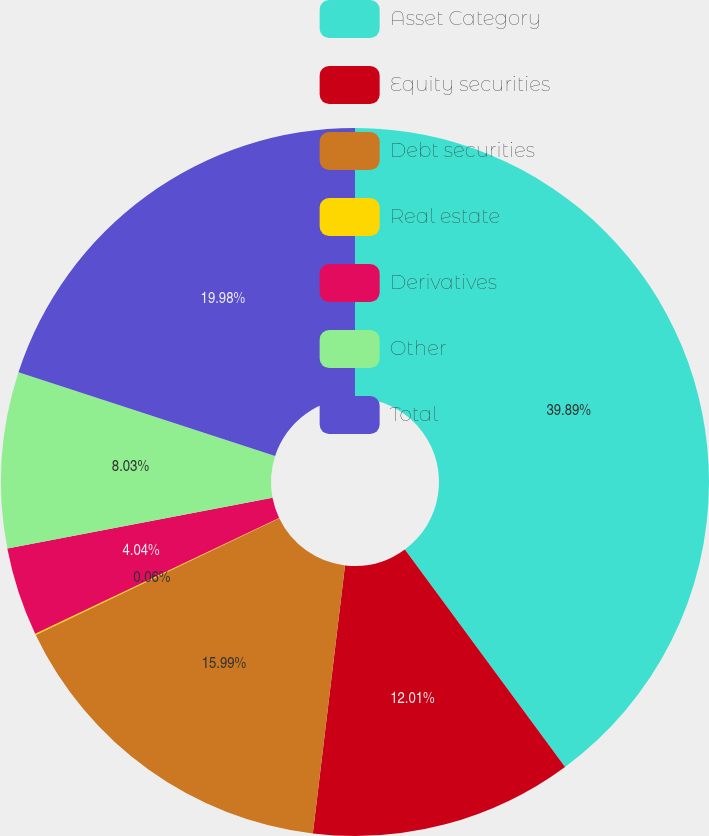Convert chart. <chart><loc_0><loc_0><loc_500><loc_500><pie_chart><fcel>Asset Category<fcel>Equity securities<fcel>Debt securities<fcel>Real estate<fcel>Derivatives<fcel>Other<fcel>Total<nl><fcel>39.89%<fcel>12.01%<fcel>15.99%<fcel>0.06%<fcel>4.04%<fcel>8.03%<fcel>19.98%<nl></chart> 